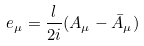Convert formula to latex. <formula><loc_0><loc_0><loc_500><loc_500>e _ { \mu } = \frac { l } { 2 i } ( A _ { \mu } - \bar { A } _ { \mu } )</formula> 